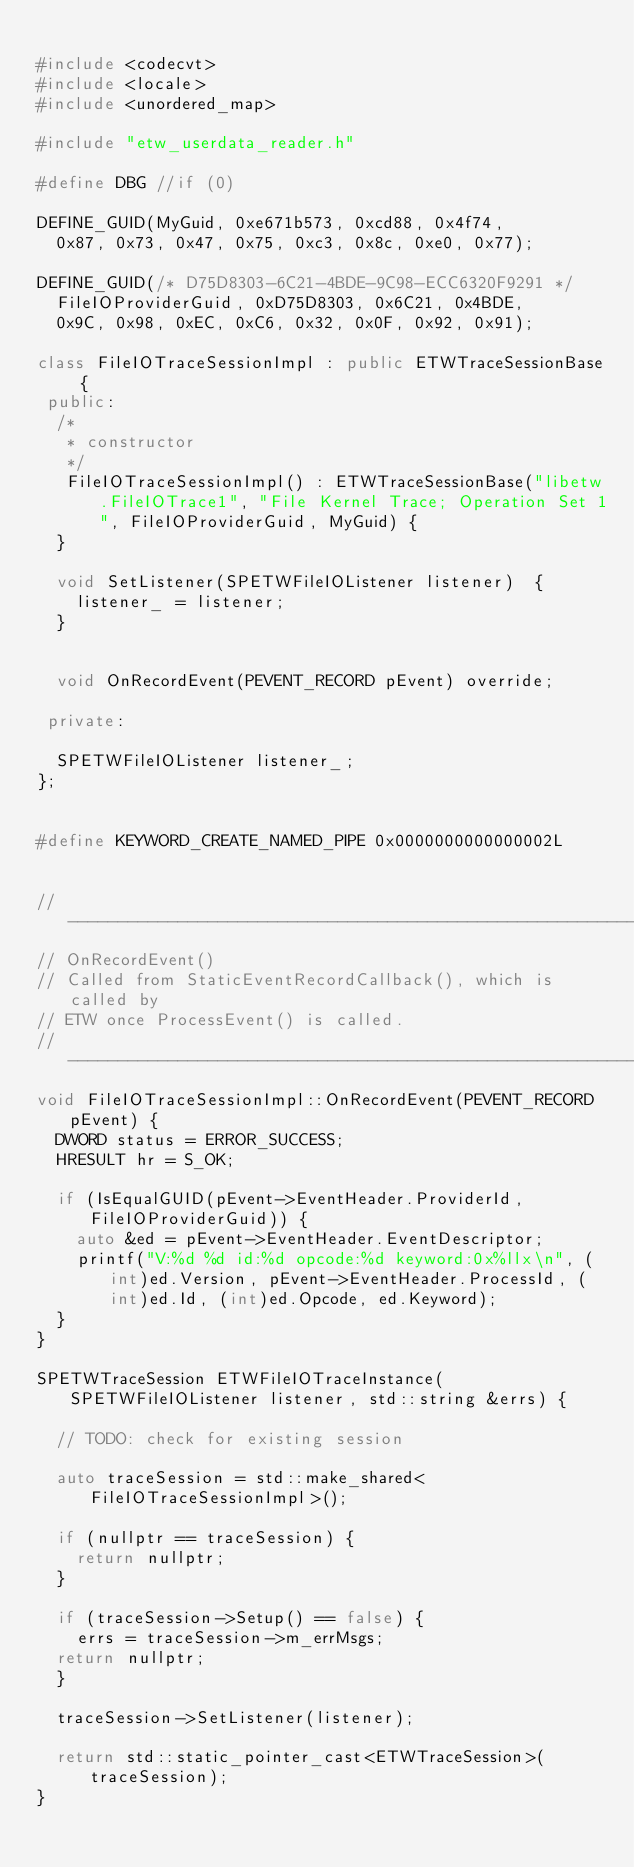<code> <loc_0><loc_0><loc_500><loc_500><_C++_>
#include <codecvt>
#include <locale>
#include <unordered_map>

#include "etw_userdata_reader.h"

#define DBG //if (0)

DEFINE_GUID(MyGuid, 0xe671b573, 0xcd88, 0x4f74,
	0x87, 0x73, 0x47, 0x75, 0xc3, 0x8c, 0xe0, 0x77);

DEFINE_GUID(/* D75D8303-6C21-4BDE-9C98-ECC6320F9291 */
	FileIOProviderGuid, 0xD75D8303, 0x6C21, 0x4BDE,
	0x9C, 0x98, 0xEC, 0xC6, 0x32, 0x0F, 0x92, 0x91);

class FileIOTraceSessionImpl : public ETWTraceSessionBase {
 public:
  /*
   * constructor
   */
	 FileIOTraceSessionImpl() : ETWTraceSessionBase("libetw.FileIOTrace1", "File Kernel Trace; Operation Set 1", FileIOProviderGuid, MyGuid) {
  }

  void SetListener(SPETWFileIOListener listener)  {
    listener_ = listener;
  }


  void OnRecordEvent(PEVENT_RECORD pEvent) override;

 private:

  SPETWFileIOListener listener_;
};


#define KEYWORD_CREATE_NAMED_PIPE 0x0000000000000002L


//---------------------------------------------------------------------
// OnRecordEvent()
// Called from StaticEventRecordCallback(), which is called by
// ETW once ProcessEvent() is called.
//---------------------------------------------------------------------
void FileIOTraceSessionImpl::OnRecordEvent(PEVENT_RECORD pEvent) {
  DWORD status = ERROR_SUCCESS;
  HRESULT hr = S_OK;

  if (IsEqualGUID(pEvent->EventHeader.ProviderId, FileIOProviderGuid)) {
	  auto &ed = pEvent->EventHeader.EventDescriptor;
	  printf("V:%d %d id:%d opcode:%d keyword:0x%llx\n", (int)ed.Version, pEvent->EventHeader.ProcessId, (int)ed.Id, (int)ed.Opcode, ed.Keyword);
  }
}

SPETWTraceSession ETWFileIOTraceInstance(SPETWFileIOListener listener, std::string &errs) {

  // TODO: check for existing session

  auto traceSession = std::make_shared<FileIOTraceSessionImpl>();
  
  if (nullptr == traceSession) {
    return nullptr;
  }

  if (traceSession->Setup() == false) {
    errs = traceSession->m_errMsgs;
	return nullptr;
  }

  traceSession->SetListener(listener);

  return std::static_pointer_cast<ETWTraceSession>(traceSession);
}
</code> 